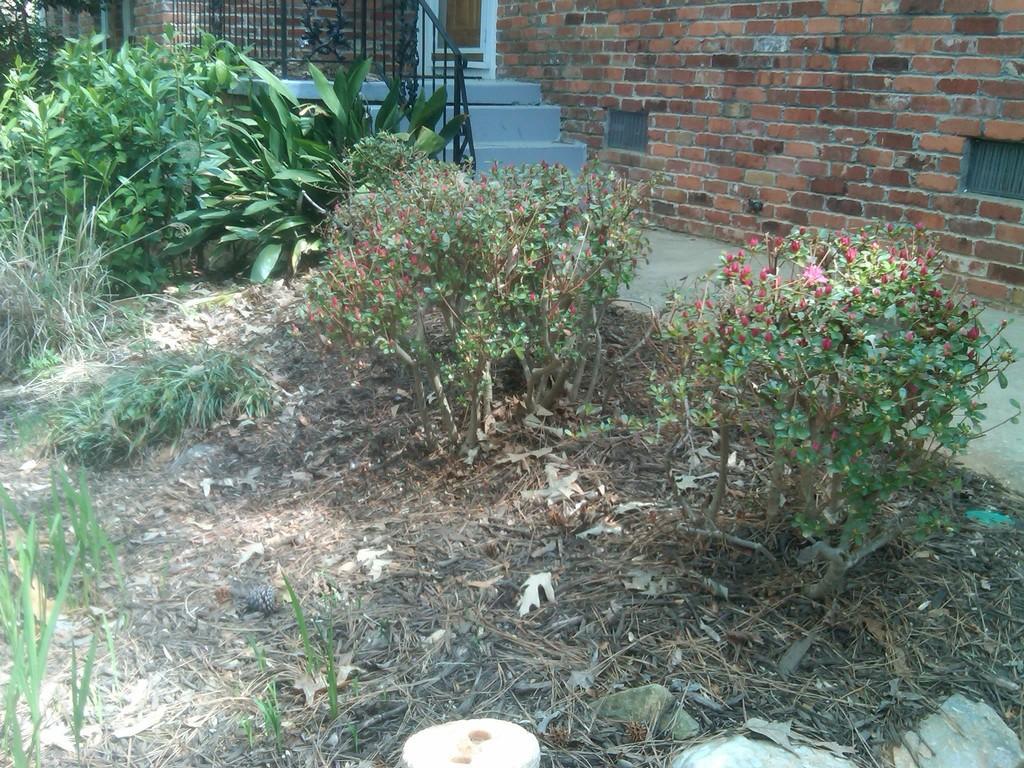In one or two sentences, can you explain what this image depicts? In this picture, we can see the wall with door, stairs, railing, path, and we can see ground with dry leaves and some plants with flowers, grass. 